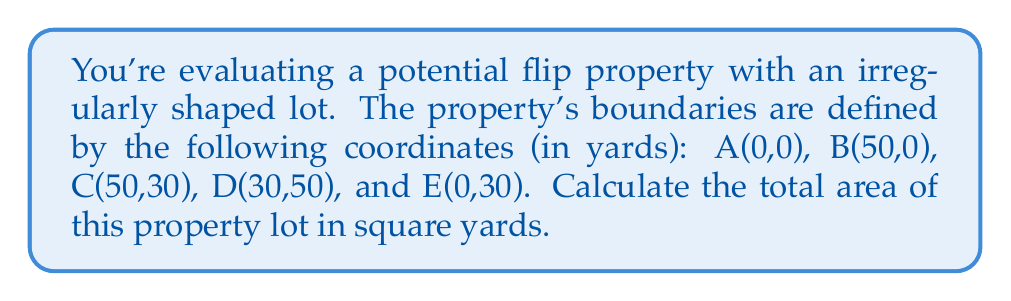Teach me how to tackle this problem. To calculate the area of this irregularly shaped lot, we can use the Shoelace formula (also known as the surveyor's formula). This method works for any polygon given its vertices.

Step 1: List the coordinates in order, repeating the first coordinate at the end.
$$(x_1, y_1), (x_2, y_2), ..., (x_n, y_n), (x_1, y_1)$$

For our lot: (0,0), (50,0), (50,30), (30,50), (0,30), (0,0)

Step 2: Apply the Shoelace formula:

$$\text{Area} = \frac{1}{2}|(x_1y_2 + x_2y_3 + ... + x_ny_1) - (y_1x_2 + y_2x_3 + ... + y_nx_1)|$$

Step 3: Calculate each term:
$$(0 \cdot 0) + (50 \cdot 30) + (50 \cdot 50) + (30 \cdot 30) + (0 \cdot 0) = 1500 + 2500 + 900 = 4900$$
$$(0 \cdot 50) + (0 \cdot 50) + (30 \cdot 30) + (50 \cdot 0) + (30 \cdot 0) = 900$$

Step 4: Subtract and take the absolute value:
$$|4900 - 900| = 4000$$

Step 5: Divide by 2:
$$\frac{4000}{2} = 2000$$

Therefore, the area of the irregularly shaped lot is 2000 square yards.
Answer: 2000 square yards 